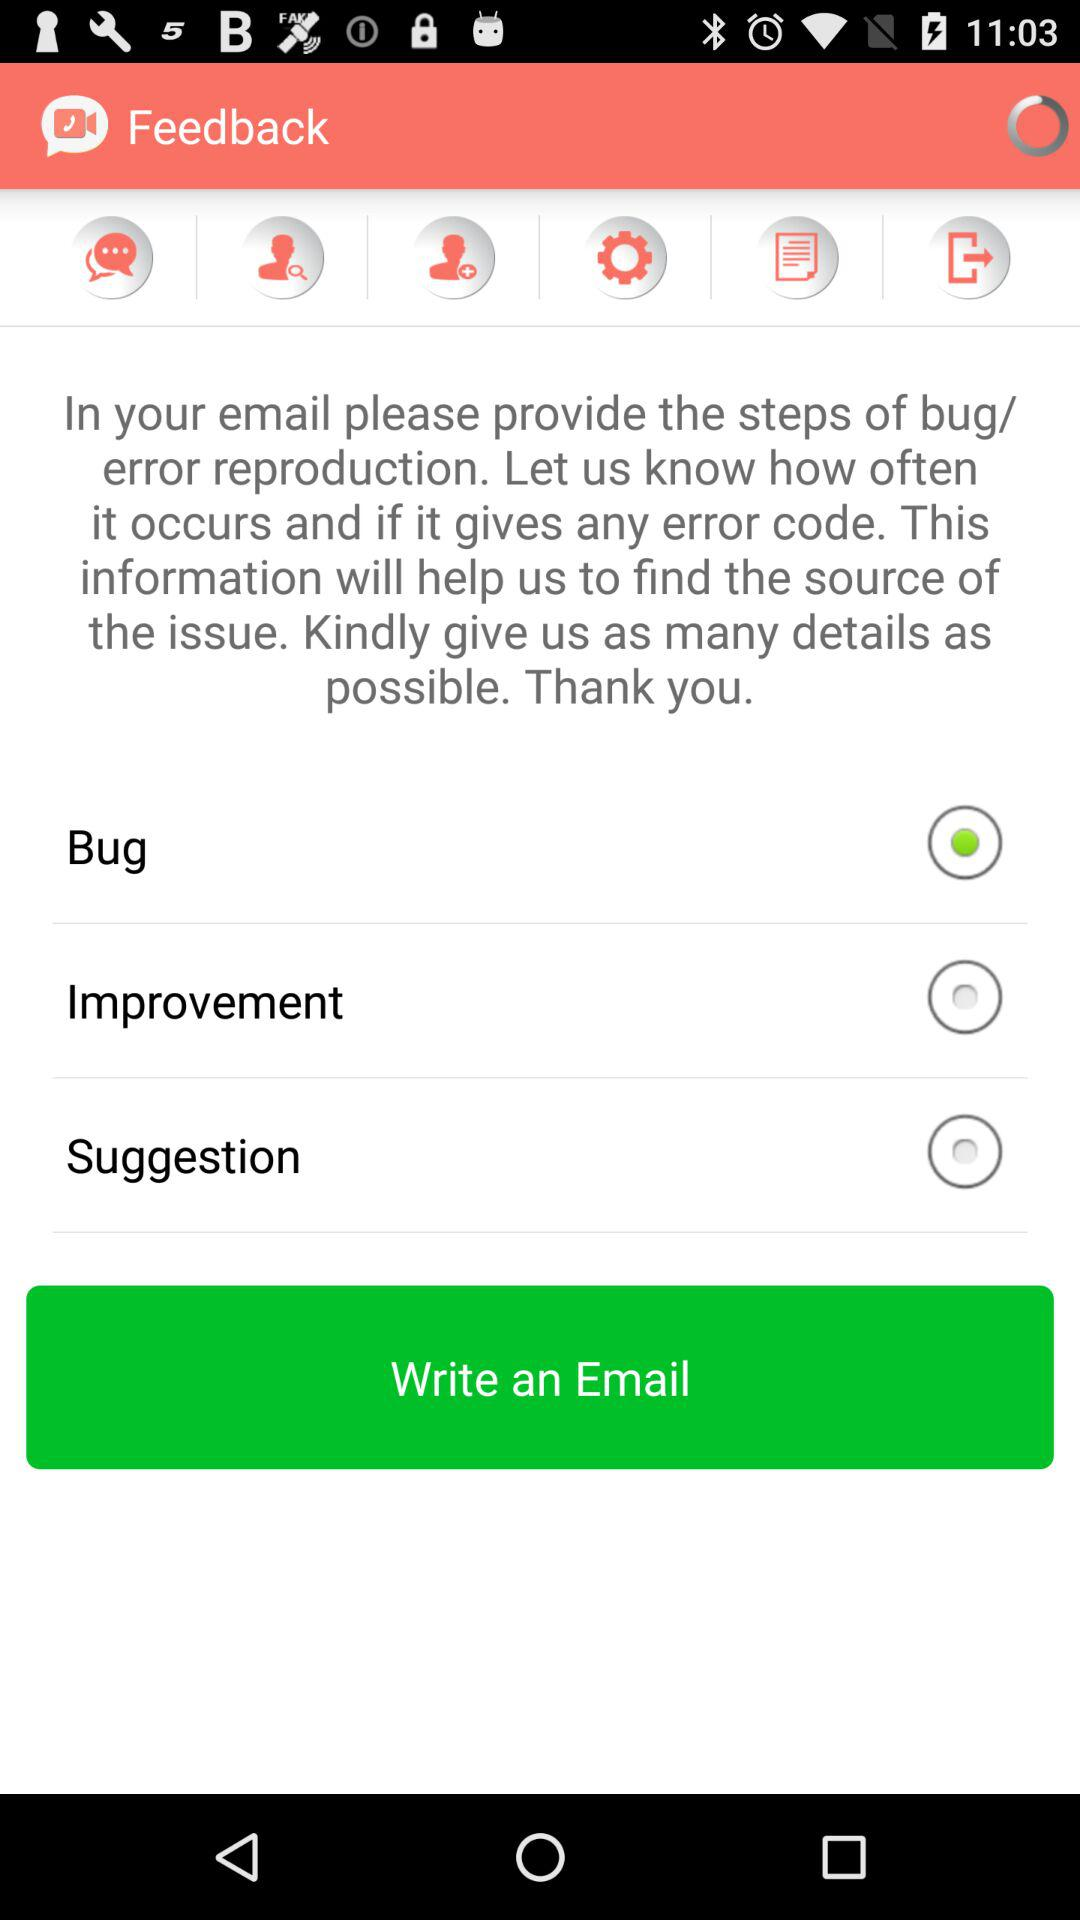What option was selected? The selected option was "Bug". 